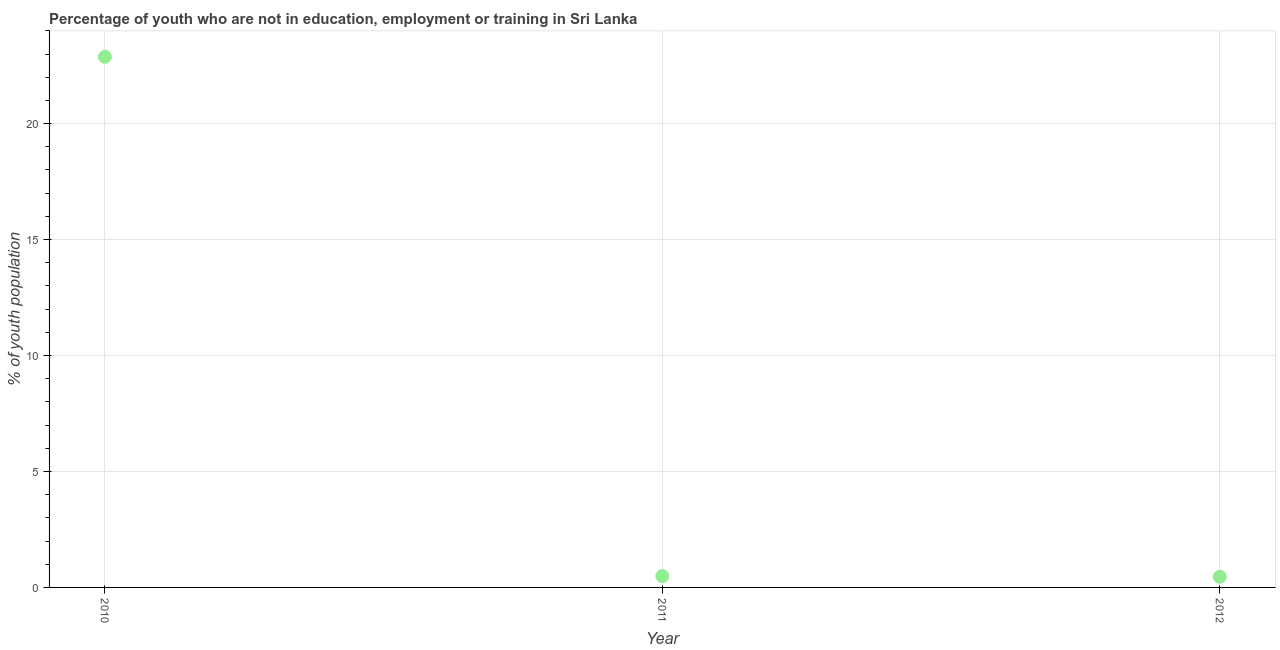What is the unemployed youth population in 2010?
Make the answer very short. 22.88. Across all years, what is the maximum unemployed youth population?
Make the answer very short. 22.88. Across all years, what is the minimum unemployed youth population?
Make the answer very short. 0.46. In which year was the unemployed youth population minimum?
Provide a short and direct response. 2012. What is the sum of the unemployed youth population?
Provide a succinct answer. 23.83. What is the difference between the unemployed youth population in 2010 and 2012?
Offer a terse response. 22.42. What is the average unemployed youth population per year?
Your response must be concise. 7.94. What is the median unemployed youth population?
Provide a short and direct response. 0.49. Do a majority of the years between 2012 and 2010 (inclusive) have unemployed youth population greater than 6 %?
Your answer should be compact. No. What is the ratio of the unemployed youth population in 2010 to that in 2012?
Ensure brevity in your answer.  49.74. Is the difference between the unemployed youth population in 2010 and 2011 greater than the difference between any two years?
Make the answer very short. No. What is the difference between the highest and the second highest unemployed youth population?
Your answer should be compact. 22.39. What is the difference between the highest and the lowest unemployed youth population?
Your answer should be very brief. 22.42. In how many years, is the unemployed youth population greater than the average unemployed youth population taken over all years?
Offer a very short reply. 1. How many dotlines are there?
Your answer should be compact. 1. How many years are there in the graph?
Make the answer very short. 3. What is the difference between two consecutive major ticks on the Y-axis?
Make the answer very short. 5. Does the graph contain grids?
Provide a succinct answer. Yes. What is the title of the graph?
Your response must be concise. Percentage of youth who are not in education, employment or training in Sri Lanka. What is the label or title of the Y-axis?
Give a very brief answer. % of youth population. What is the % of youth population in 2010?
Your answer should be very brief. 22.88. What is the % of youth population in 2011?
Offer a terse response. 0.49. What is the % of youth population in 2012?
Make the answer very short. 0.46. What is the difference between the % of youth population in 2010 and 2011?
Offer a very short reply. 22.39. What is the difference between the % of youth population in 2010 and 2012?
Give a very brief answer. 22.42. What is the difference between the % of youth population in 2011 and 2012?
Keep it short and to the point. 0.03. What is the ratio of the % of youth population in 2010 to that in 2011?
Provide a succinct answer. 46.69. What is the ratio of the % of youth population in 2010 to that in 2012?
Give a very brief answer. 49.74. What is the ratio of the % of youth population in 2011 to that in 2012?
Make the answer very short. 1.06. 